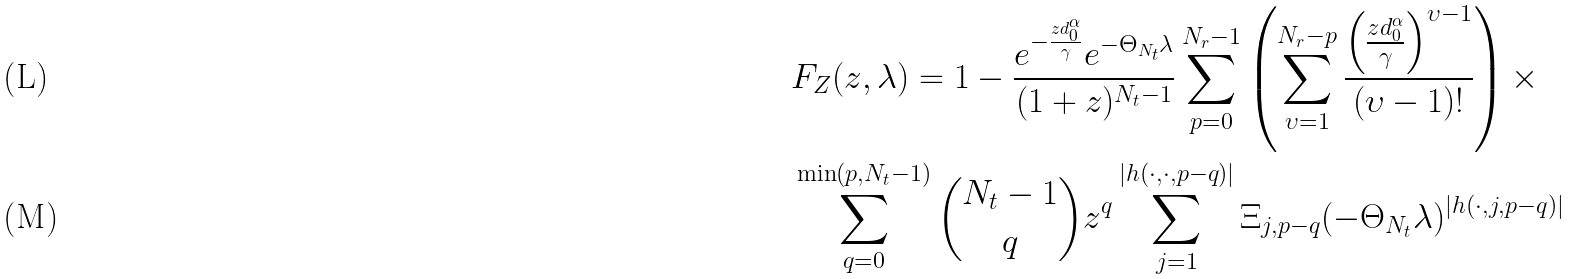Convert formula to latex. <formula><loc_0><loc_0><loc_500><loc_500>& F _ { Z } ( z , \lambda ) = 1 - \frac { e ^ { - \frac { z d _ { 0 } ^ { \alpha } } { \gamma } } e ^ { - \Theta _ { N _ { t } } \lambda } } { ( 1 + z ) ^ { N _ { t } - 1 } } \sum _ { p = 0 } ^ { N _ { r } - 1 } \left ( \sum _ { \upsilon = 1 } ^ { N _ { r } - p } \frac { \left ( \frac { z d _ { 0 } ^ { \alpha } } { \gamma } \right ) ^ { \upsilon - 1 } } { ( \upsilon - 1 ) ! } \right ) \times \\ & \sum _ { q = 0 } ^ { \min ( p , N _ { t } - 1 ) } \binom { N _ { t } - 1 } { q } z ^ { q } \sum _ { j = 1 } ^ { | h ( \cdot , \cdot , p - q ) | } \Xi _ { j , p - q } ( - \Theta _ { N _ { t } } \lambda ) ^ { | h ( \cdot , j , p - q ) | }</formula> 